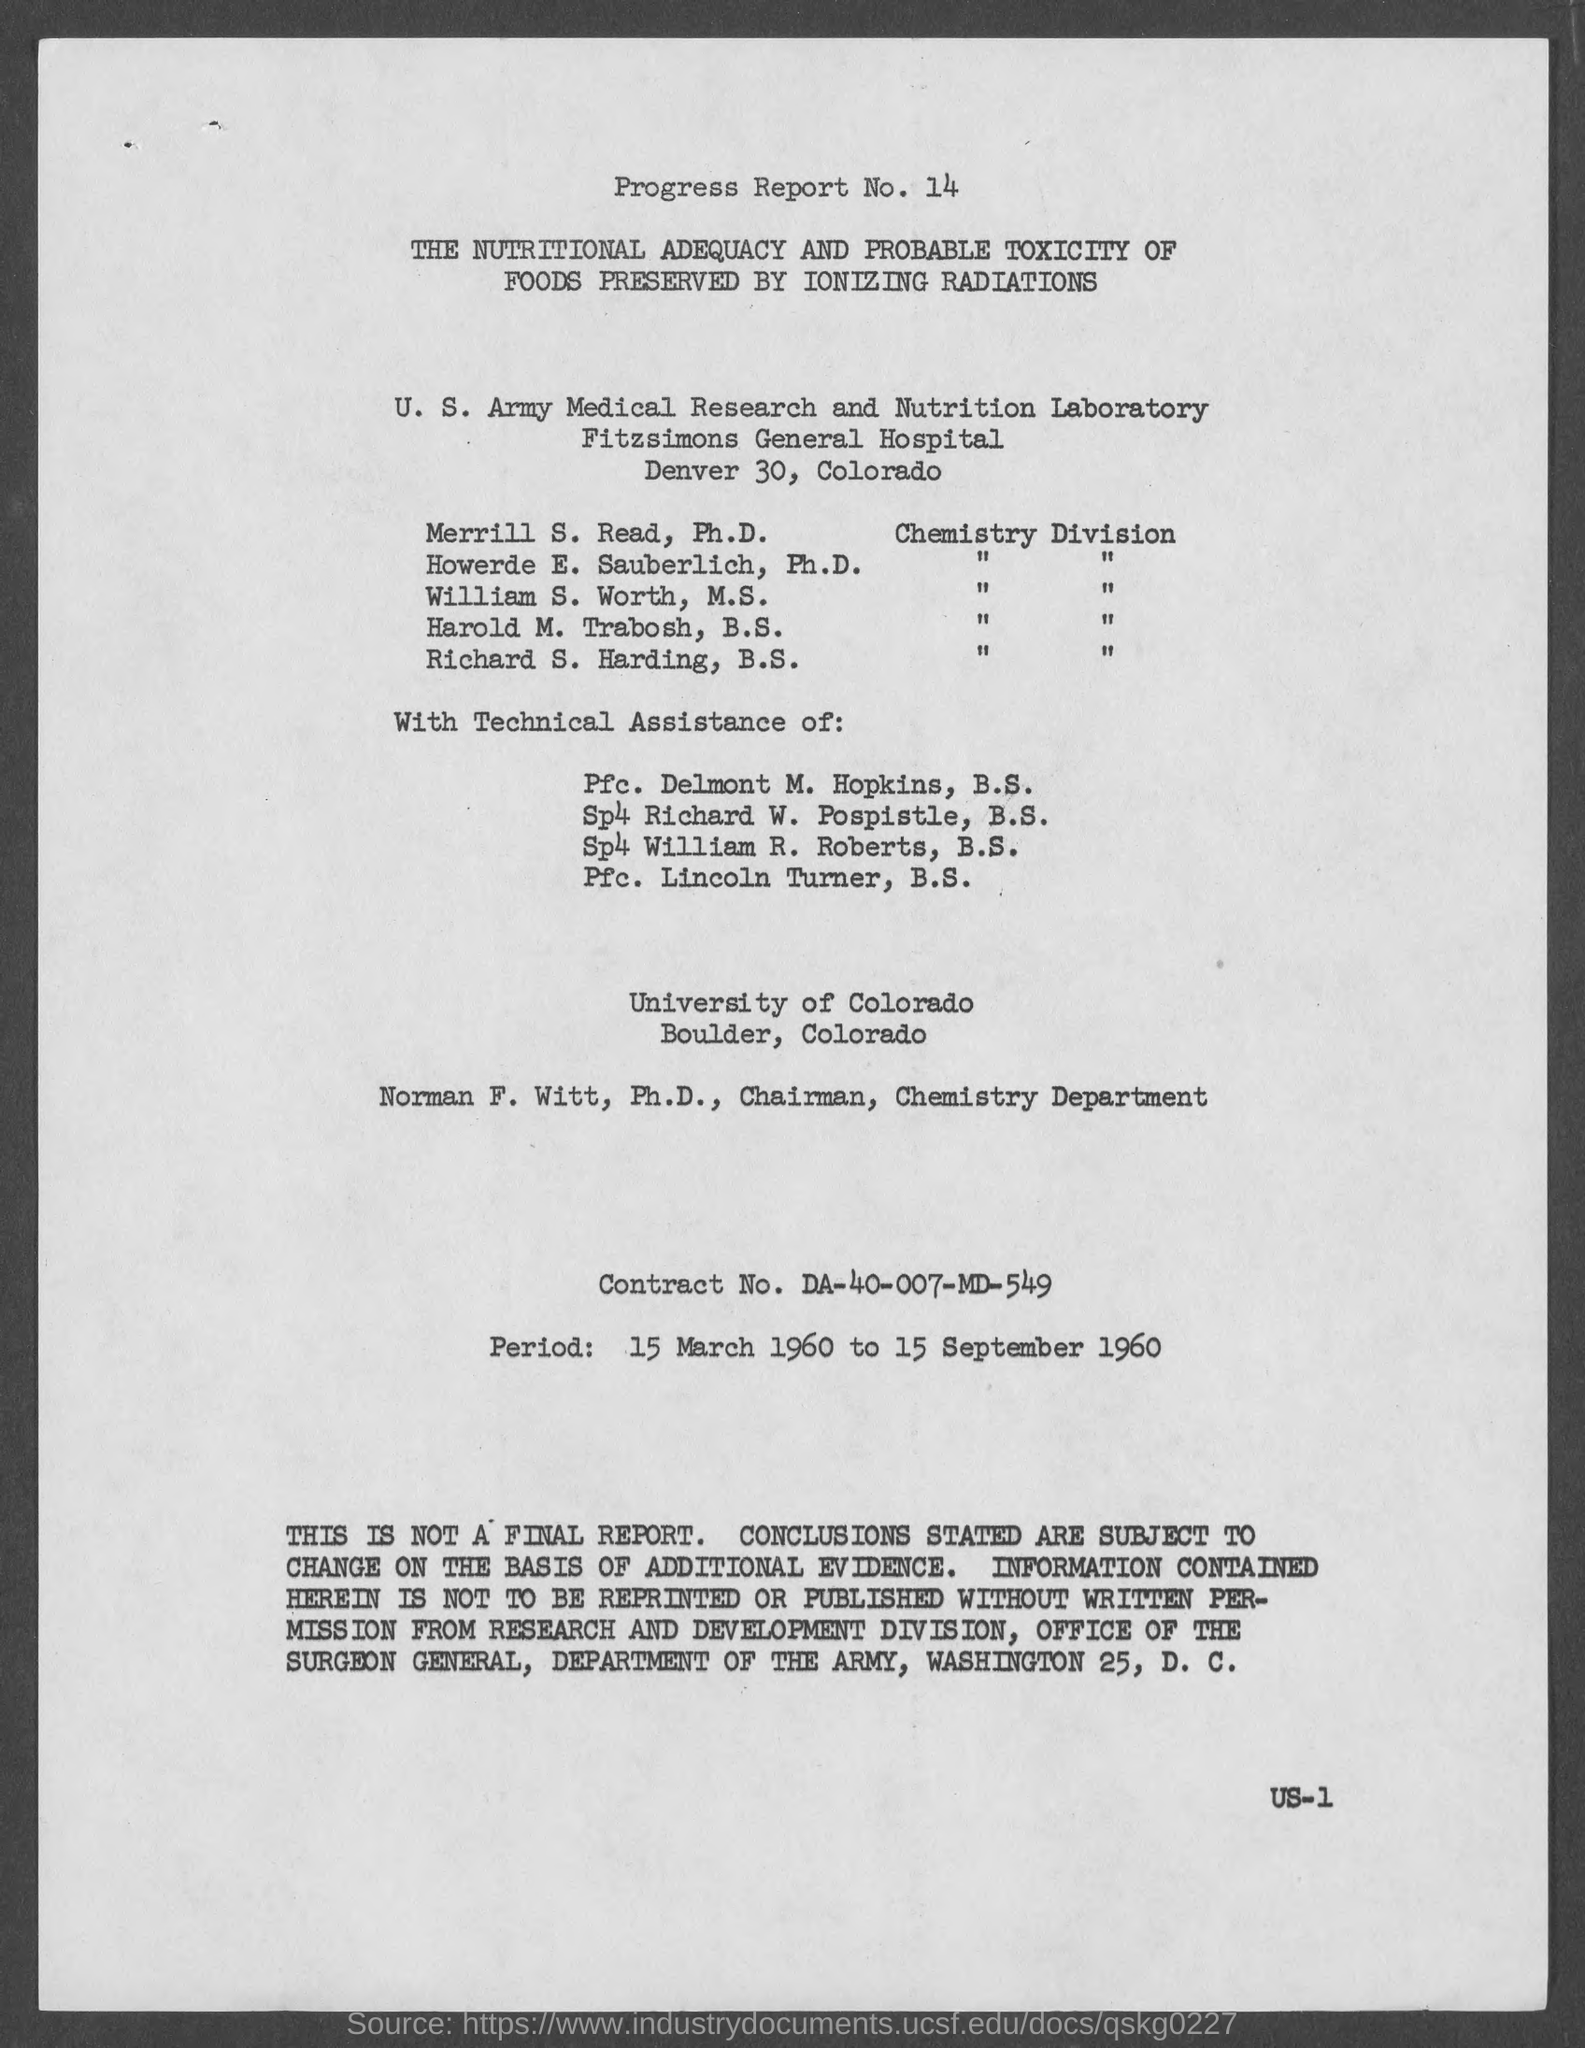What is the progress report no.?
Provide a short and direct response. 14. What is the street address of fitzsimons general hospital  ?
Keep it short and to the point. Denver 30. What is the contract no.?
Ensure brevity in your answer.  DA-40-007-MD-549. In which county is university of colorado at?
Give a very brief answer. Boulder. What is the period ?
Your answer should be very brief. 15 March 1960 to 15 September 1960. 